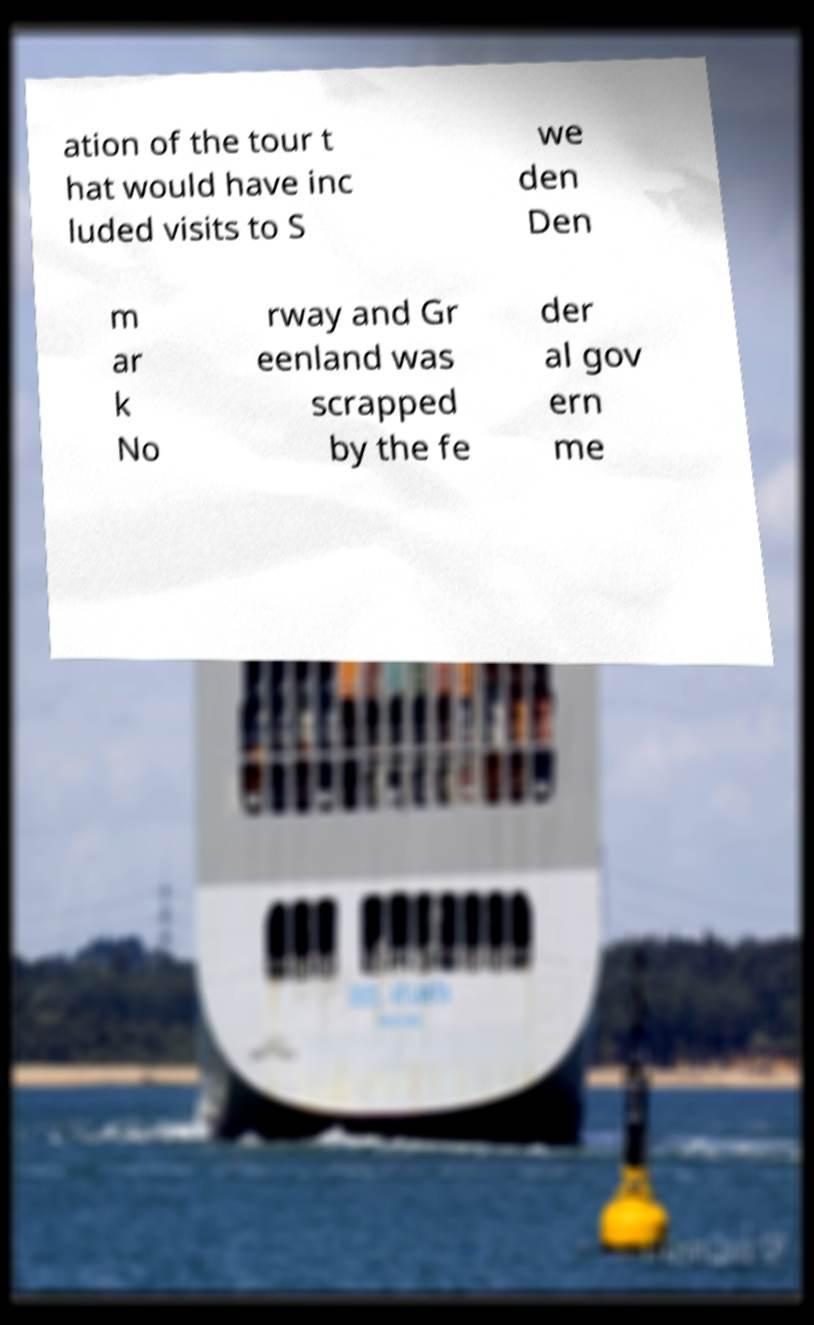Can you read and provide the text displayed in the image?This photo seems to have some interesting text. Can you extract and type it out for me? ation of the tour t hat would have inc luded visits to S we den Den m ar k No rway and Gr eenland was scrapped by the fe der al gov ern me 